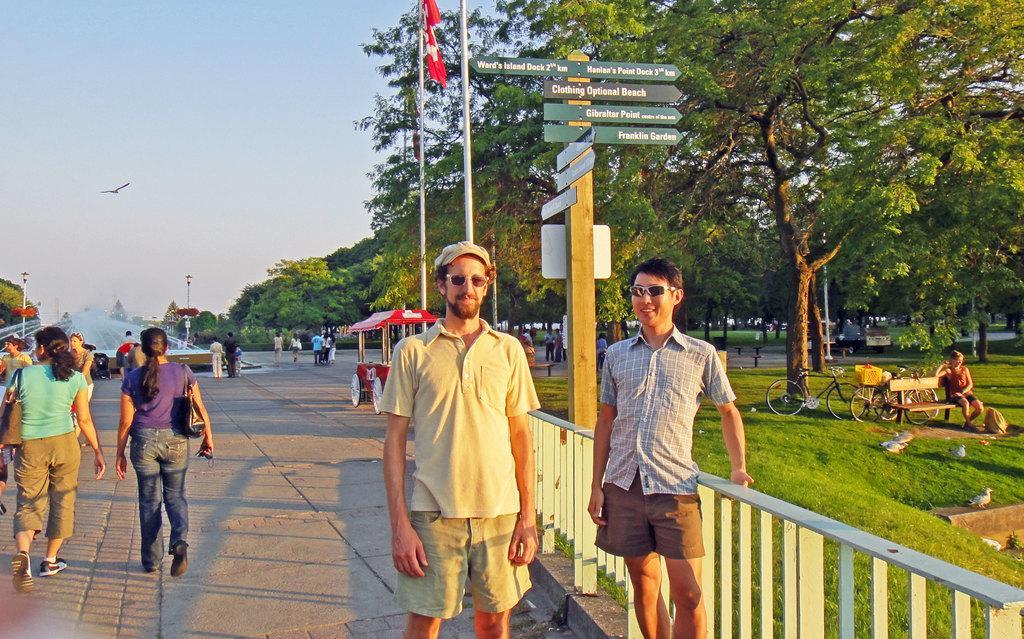Please provide a concise description of this image. In this picture I can see the path in front, on which there are number of people and on the right side of this picture I can see the grass and I see few cycles, a woman on a bench and I see few birds. In the middle of this picture I can see the fountain, number of trees, few poles and in the background I can see the sky and I can also see a bird on the left center of this image. On the top center of this image I can see a flag, which is red and white in color and I see few boards on which there is something written. 